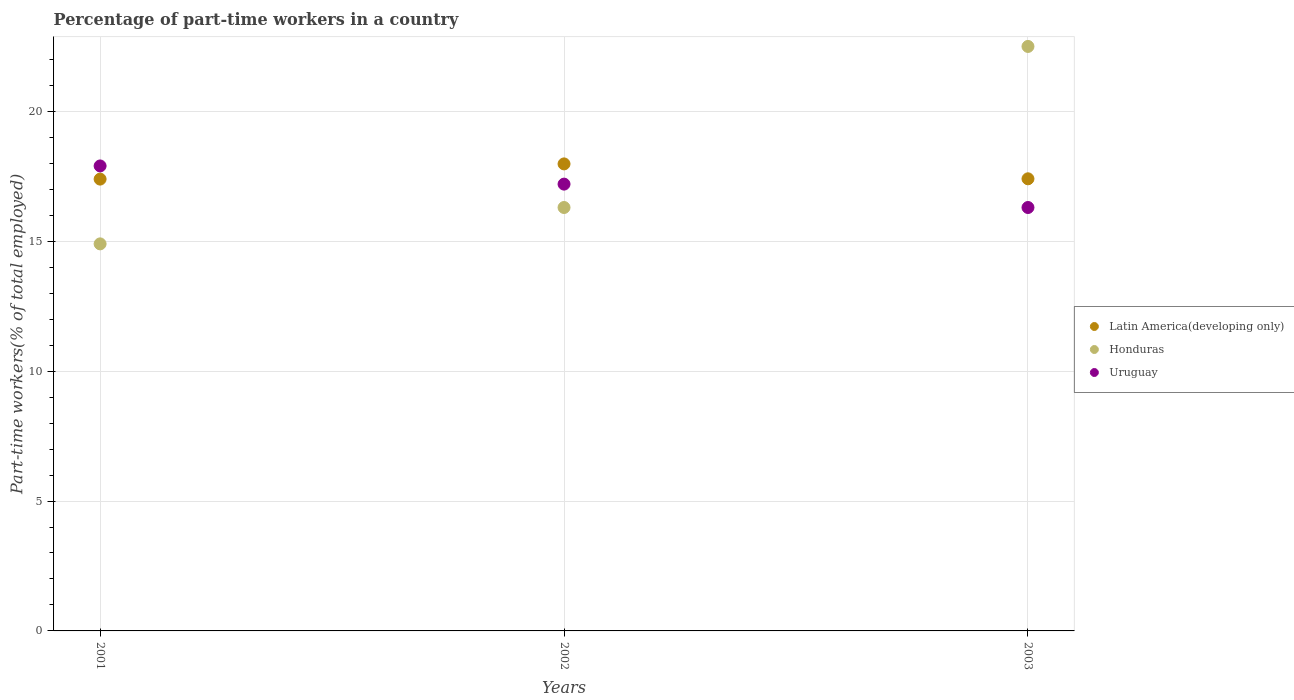Is the number of dotlines equal to the number of legend labels?
Offer a very short reply. Yes. What is the percentage of part-time workers in Honduras in 2001?
Offer a very short reply. 14.9. Across all years, what is the maximum percentage of part-time workers in Uruguay?
Offer a very short reply. 17.9. Across all years, what is the minimum percentage of part-time workers in Honduras?
Offer a terse response. 14.9. In which year was the percentage of part-time workers in Latin America(developing only) maximum?
Your answer should be compact. 2002. In which year was the percentage of part-time workers in Uruguay minimum?
Your answer should be compact. 2003. What is the total percentage of part-time workers in Latin America(developing only) in the graph?
Your answer should be very brief. 52.78. What is the difference between the percentage of part-time workers in Latin America(developing only) in 2002 and that in 2003?
Ensure brevity in your answer.  0.57. What is the difference between the percentage of part-time workers in Latin America(developing only) in 2002 and the percentage of part-time workers in Honduras in 2001?
Make the answer very short. 3.08. What is the average percentage of part-time workers in Latin America(developing only) per year?
Offer a very short reply. 17.59. In the year 2001, what is the difference between the percentage of part-time workers in Uruguay and percentage of part-time workers in Latin America(developing only)?
Keep it short and to the point. 0.51. What is the ratio of the percentage of part-time workers in Honduras in 2002 to that in 2003?
Keep it short and to the point. 0.72. Is the difference between the percentage of part-time workers in Uruguay in 2001 and 2002 greater than the difference between the percentage of part-time workers in Latin America(developing only) in 2001 and 2002?
Your answer should be compact. Yes. What is the difference between the highest and the second highest percentage of part-time workers in Uruguay?
Your answer should be compact. 0.7. What is the difference between the highest and the lowest percentage of part-time workers in Latin America(developing only)?
Provide a succinct answer. 0.59. In how many years, is the percentage of part-time workers in Honduras greater than the average percentage of part-time workers in Honduras taken over all years?
Your response must be concise. 1. Is the sum of the percentage of part-time workers in Latin America(developing only) in 2001 and 2003 greater than the maximum percentage of part-time workers in Honduras across all years?
Make the answer very short. Yes. Is it the case that in every year, the sum of the percentage of part-time workers in Uruguay and percentage of part-time workers in Honduras  is greater than the percentage of part-time workers in Latin America(developing only)?
Your answer should be very brief. Yes. How many years are there in the graph?
Give a very brief answer. 3. How many legend labels are there?
Your answer should be compact. 3. How are the legend labels stacked?
Your answer should be compact. Vertical. What is the title of the graph?
Make the answer very short. Percentage of part-time workers in a country. What is the label or title of the X-axis?
Offer a very short reply. Years. What is the label or title of the Y-axis?
Ensure brevity in your answer.  Part-time workers(% of total employed). What is the Part-time workers(% of total employed) in Latin America(developing only) in 2001?
Your response must be concise. 17.39. What is the Part-time workers(% of total employed) of Honduras in 2001?
Offer a terse response. 14.9. What is the Part-time workers(% of total employed) of Uruguay in 2001?
Offer a terse response. 17.9. What is the Part-time workers(% of total employed) in Latin America(developing only) in 2002?
Offer a terse response. 17.98. What is the Part-time workers(% of total employed) in Honduras in 2002?
Offer a terse response. 16.3. What is the Part-time workers(% of total employed) in Uruguay in 2002?
Your answer should be very brief. 17.2. What is the Part-time workers(% of total employed) of Latin America(developing only) in 2003?
Keep it short and to the point. 17.4. What is the Part-time workers(% of total employed) of Uruguay in 2003?
Make the answer very short. 16.3. Across all years, what is the maximum Part-time workers(% of total employed) in Latin America(developing only)?
Your answer should be very brief. 17.98. Across all years, what is the maximum Part-time workers(% of total employed) of Uruguay?
Give a very brief answer. 17.9. Across all years, what is the minimum Part-time workers(% of total employed) in Latin America(developing only)?
Provide a succinct answer. 17.39. Across all years, what is the minimum Part-time workers(% of total employed) of Honduras?
Provide a short and direct response. 14.9. Across all years, what is the minimum Part-time workers(% of total employed) of Uruguay?
Give a very brief answer. 16.3. What is the total Part-time workers(% of total employed) in Latin America(developing only) in the graph?
Provide a short and direct response. 52.78. What is the total Part-time workers(% of total employed) of Honduras in the graph?
Keep it short and to the point. 53.7. What is the total Part-time workers(% of total employed) in Uruguay in the graph?
Your answer should be compact. 51.4. What is the difference between the Part-time workers(% of total employed) in Latin America(developing only) in 2001 and that in 2002?
Offer a terse response. -0.59. What is the difference between the Part-time workers(% of total employed) in Honduras in 2001 and that in 2002?
Provide a short and direct response. -1.4. What is the difference between the Part-time workers(% of total employed) of Latin America(developing only) in 2001 and that in 2003?
Provide a succinct answer. -0.01. What is the difference between the Part-time workers(% of total employed) in Honduras in 2001 and that in 2003?
Keep it short and to the point. -7.6. What is the difference between the Part-time workers(% of total employed) in Latin America(developing only) in 2002 and that in 2003?
Your response must be concise. 0.57. What is the difference between the Part-time workers(% of total employed) of Uruguay in 2002 and that in 2003?
Your response must be concise. 0.9. What is the difference between the Part-time workers(% of total employed) of Latin America(developing only) in 2001 and the Part-time workers(% of total employed) of Honduras in 2002?
Make the answer very short. 1.09. What is the difference between the Part-time workers(% of total employed) of Latin America(developing only) in 2001 and the Part-time workers(% of total employed) of Uruguay in 2002?
Make the answer very short. 0.19. What is the difference between the Part-time workers(% of total employed) in Honduras in 2001 and the Part-time workers(% of total employed) in Uruguay in 2002?
Your response must be concise. -2.3. What is the difference between the Part-time workers(% of total employed) of Latin America(developing only) in 2001 and the Part-time workers(% of total employed) of Honduras in 2003?
Your response must be concise. -5.11. What is the difference between the Part-time workers(% of total employed) of Latin America(developing only) in 2001 and the Part-time workers(% of total employed) of Uruguay in 2003?
Offer a very short reply. 1.09. What is the difference between the Part-time workers(% of total employed) of Latin America(developing only) in 2002 and the Part-time workers(% of total employed) of Honduras in 2003?
Your answer should be compact. -4.52. What is the difference between the Part-time workers(% of total employed) in Latin America(developing only) in 2002 and the Part-time workers(% of total employed) in Uruguay in 2003?
Ensure brevity in your answer.  1.68. What is the average Part-time workers(% of total employed) in Latin America(developing only) per year?
Provide a short and direct response. 17.59. What is the average Part-time workers(% of total employed) of Uruguay per year?
Your response must be concise. 17.13. In the year 2001, what is the difference between the Part-time workers(% of total employed) of Latin America(developing only) and Part-time workers(% of total employed) of Honduras?
Your answer should be compact. 2.49. In the year 2001, what is the difference between the Part-time workers(% of total employed) in Latin America(developing only) and Part-time workers(% of total employed) in Uruguay?
Your answer should be very brief. -0.51. In the year 2001, what is the difference between the Part-time workers(% of total employed) of Honduras and Part-time workers(% of total employed) of Uruguay?
Make the answer very short. -3. In the year 2002, what is the difference between the Part-time workers(% of total employed) in Latin America(developing only) and Part-time workers(% of total employed) in Honduras?
Your response must be concise. 1.68. In the year 2002, what is the difference between the Part-time workers(% of total employed) of Latin America(developing only) and Part-time workers(% of total employed) of Uruguay?
Provide a short and direct response. 0.78. In the year 2002, what is the difference between the Part-time workers(% of total employed) in Honduras and Part-time workers(% of total employed) in Uruguay?
Provide a short and direct response. -0.9. In the year 2003, what is the difference between the Part-time workers(% of total employed) in Latin America(developing only) and Part-time workers(% of total employed) in Honduras?
Provide a succinct answer. -5.1. In the year 2003, what is the difference between the Part-time workers(% of total employed) in Latin America(developing only) and Part-time workers(% of total employed) in Uruguay?
Your answer should be compact. 1.1. What is the ratio of the Part-time workers(% of total employed) of Latin America(developing only) in 2001 to that in 2002?
Make the answer very short. 0.97. What is the ratio of the Part-time workers(% of total employed) in Honduras in 2001 to that in 2002?
Give a very brief answer. 0.91. What is the ratio of the Part-time workers(% of total employed) in Uruguay in 2001 to that in 2002?
Offer a terse response. 1.04. What is the ratio of the Part-time workers(% of total employed) of Honduras in 2001 to that in 2003?
Your answer should be very brief. 0.66. What is the ratio of the Part-time workers(% of total employed) of Uruguay in 2001 to that in 2003?
Keep it short and to the point. 1.1. What is the ratio of the Part-time workers(% of total employed) in Latin America(developing only) in 2002 to that in 2003?
Offer a very short reply. 1.03. What is the ratio of the Part-time workers(% of total employed) in Honduras in 2002 to that in 2003?
Your answer should be compact. 0.72. What is the ratio of the Part-time workers(% of total employed) in Uruguay in 2002 to that in 2003?
Provide a short and direct response. 1.06. What is the difference between the highest and the second highest Part-time workers(% of total employed) in Latin America(developing only)?
Provide a short and direct response. 0.57. What is the difference between the highest and the lowest Part-time workers(% of total employed) of Latin America(developing only)?
Your answer should be very brief. 0.59. What is the difference between the highest and the lowest Part-time workers(% of total employed) of Uruguay?
Your answer should be very brief. 1.6. 